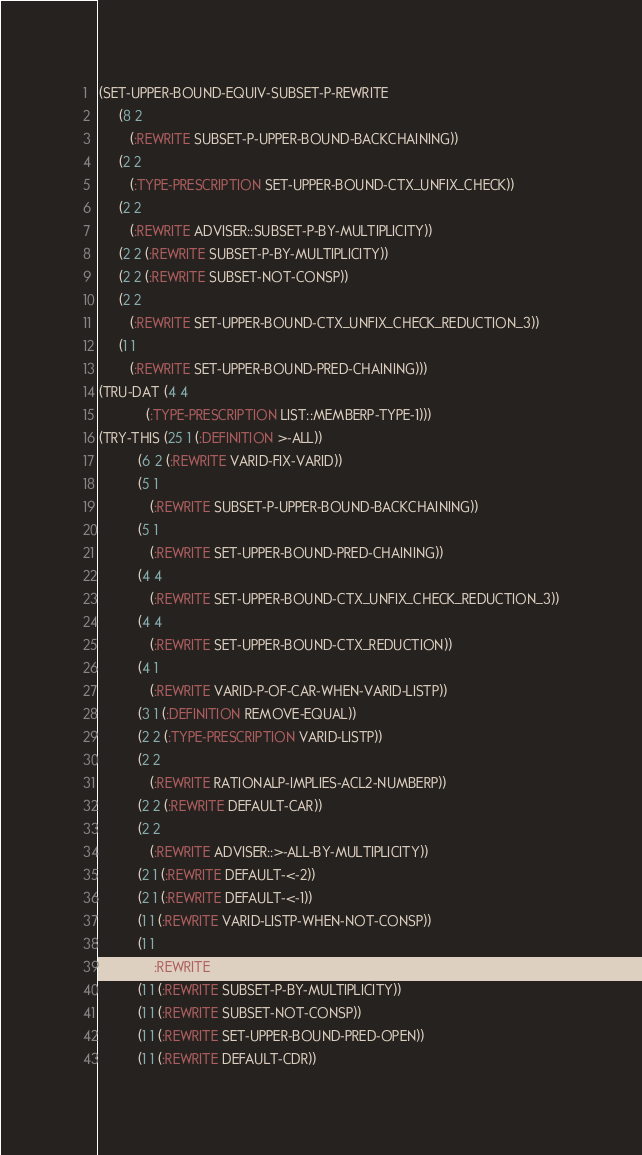<code> <loc_0><loc_0><loc_500><loc_500><_Lisp_>(SET-UPPER-BOUND-EQUIV-SUBSET-P-REWRITE
     (8 2
        (:REWRITE SUBSET-P-UPPER-BOUND-BACKCHAINING))
     (2 2
        (:TYPE-PRESCRIPTION SET-UPPER-BOUND-CTX_UNFIX_CHECK))
     (2 2
        (:REWRITE ADVISER::SUBSET-P-BY-MULTIPLICITY))
     (2 2 (:REWRITE SUBSET-P-BY-MULTIPLICITY))
     (2 2 (:REWRITE SUBSET-NOT-CONSP))
     (2 2
        (:REWRITE SET-UPPER-BOUND-CTX_UNFIX_CHECK_REDUCTION_3))
     (1 1
        (:REWRITE SET-UPPER-BOUND-PRED-CHAINING)))
(TRU-DAT (4 4
            (:TYPE-PRESCRIPTION LIST::MEMBERP-TYPE-1)))
(TRY-THIS (25 1 (:DEFINITION >-ALL))
          (6 2 (:REWRITE VARID-FIX-VARID))
          (5 1
             (:REWRITE SUBSET-P-UPPER-BOUND-BACKCHAINING))
          (5 1
             (:REWRITE SET-UPPER-BOUND-PRED-CHAINING))
          (4 4
             (:REWRITE SET-UPPER-BOUND-CTX_UNFIX_CHECK_REDUCTION_3))
          (4 4
             (:REWRITE SET-UPPER-BOUND-CTX_REDUCTION))
          (4 1
             (:REWRITE VARID-P-OF-CAR-WHEN-VARID-LISTP))
          (3 1 (:DEFINITION REMOVE-EQUAL))
          (2 2 (:TYPE-PRESCRIPTION VARID-LISTP))
          (2 2
             (:REWRITE RATIONALP-IMPLIES-ACL2-NUMBERP))
          (2 2 (:REWRITE DEFAULT-CAR))
          (2 2
             (:REWRITE ADVISER::>-ALL-BY-MULTIPLICITY))
          (2 1 (:REWRITE DEFAULT-<-2))
          (2 1 (:REWRITE DEFAULT-<-1))
          (1 1 (:REWRITE VARID-LISTP-WHEN-NOT-CONSP))
          (1 1
             (:REWRITE ADVISER::SUBSET-P-BY-MULTIPLICITY))
          (1 1 (:REWRITE SUBSET-P-BY-MULTIPLICITY))
          (1 1 (:REWRITE SUBSET-NOT-CONSP))
          (1 1 (:REWRITE SET-UPPER-BOUND-PRED-OPEN))
          (1 1 (:REWRITE DEFAULT-CDR))</code> 